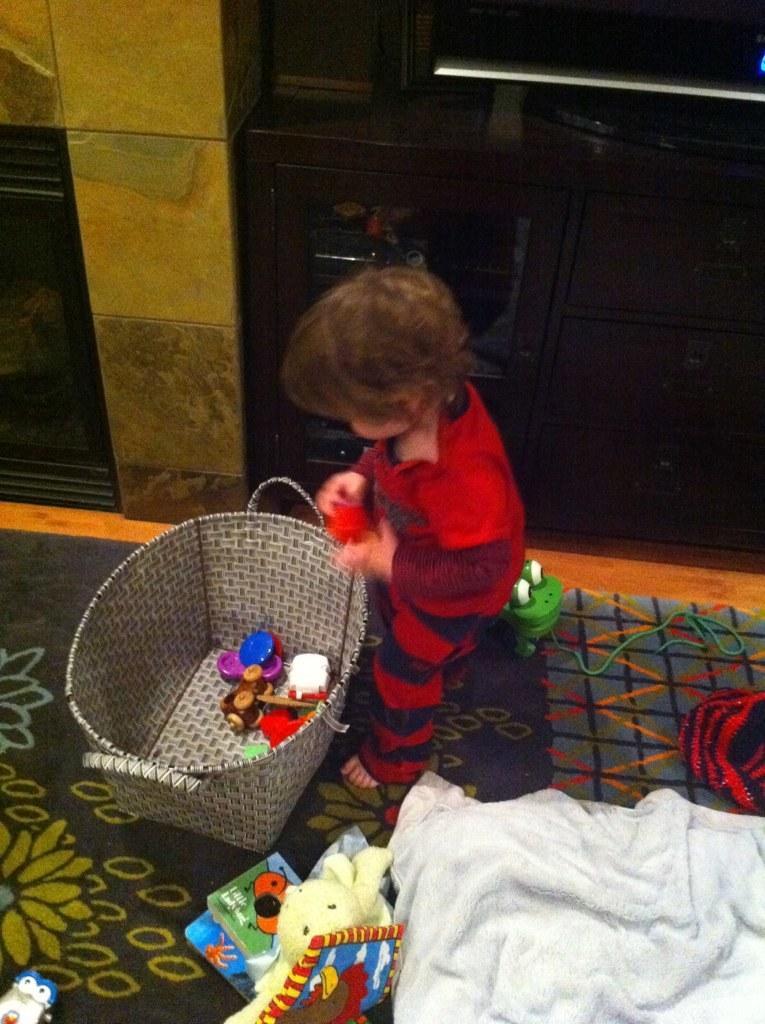Describe this image in one or two sentences. This is an inside view. Here I can see a baby is standing facing towards the left side. In front of the baby there is a basket. In the basket there are some toys. At the bottom there is a bed sheet and the few toys are placed on the ground. At the top there is a wall and also there is a metal rod which is attached to the wall. 